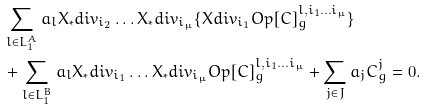Convert formula to latex. <formula><loc_0><loc_0><loc_500><loc_500>& \sum _ { l \in L ^ { A } _ { 1 } } a _ { l } X _ { * } d i v _ { i _ { 2 } } \dots X _ { * } d i v _ { i _ { \mu } } \{ X d i v _ { i _ { 1 } } O p [ C ] ^ { l , i _ { 1 } \dots i _ { \mu } } _ { g } \} \\ & + \sum _ { l \in L ^ { B } _ { 1 } } a _ { l } X _ { * } d i v _ { i _ { 1 } } \dots X _ { * } d i v _ { i _ { \mu } } O p [ C ] ^ { l , i _ { 1 } \dots i _ { \mu } } _ { g } + \sum _ { j \in J } a _ { j } C ^ { j } _ { g } = 0 .</formula> 